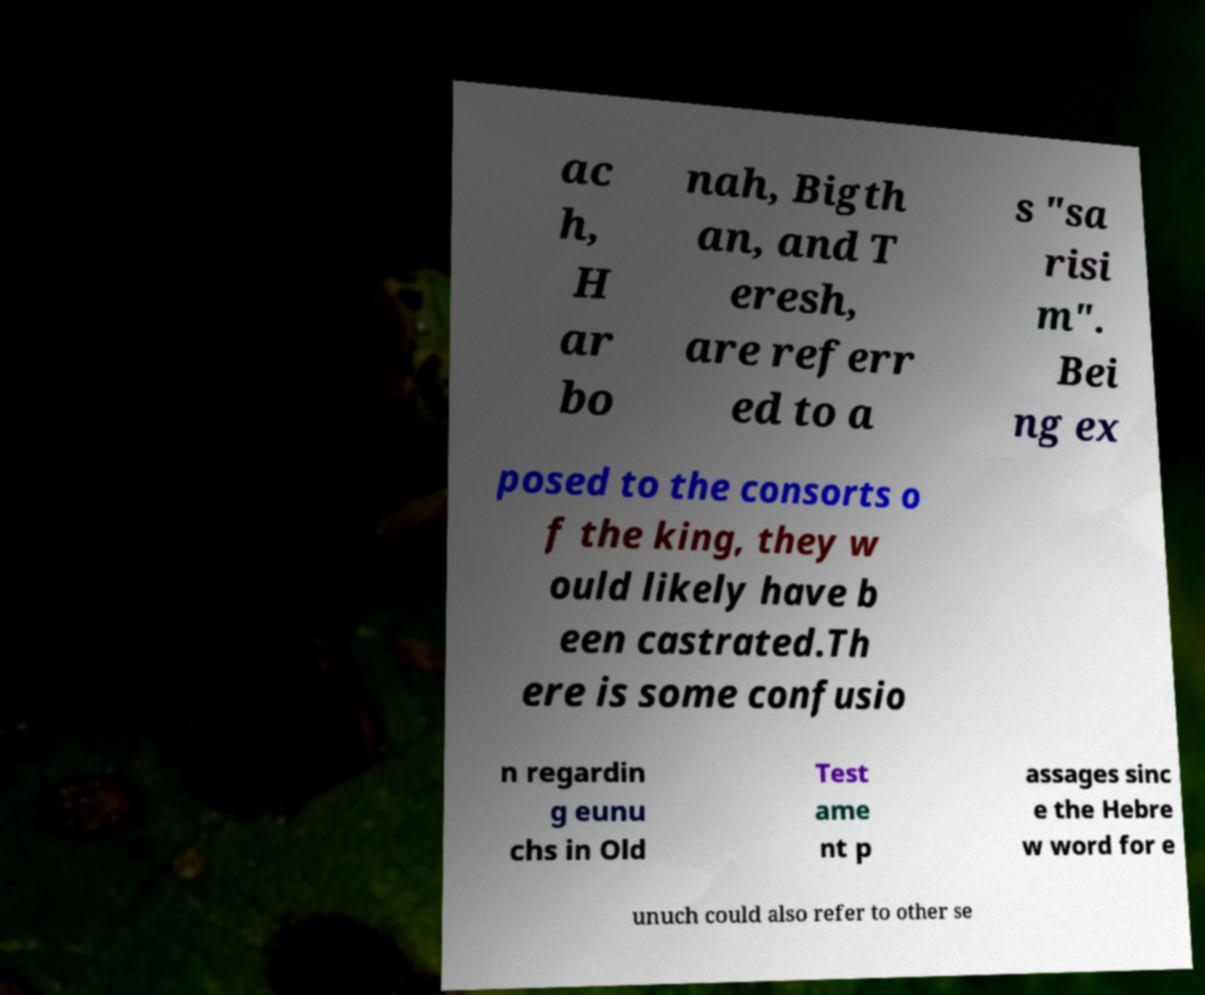Can you accurately transcribe the text from the provided image for me? ac h, H ar bo nah, Bigth an, and T eresh, are referr ed to a s "sa risi m". Bei ng ex posed to the consorts o f the king, they w ould likely have b een castrated.Th ere is some confusio n regardin g eunu chs in Old Test ame nt p assages sinc e the Hebre w word for e unuch could also refer to other se 